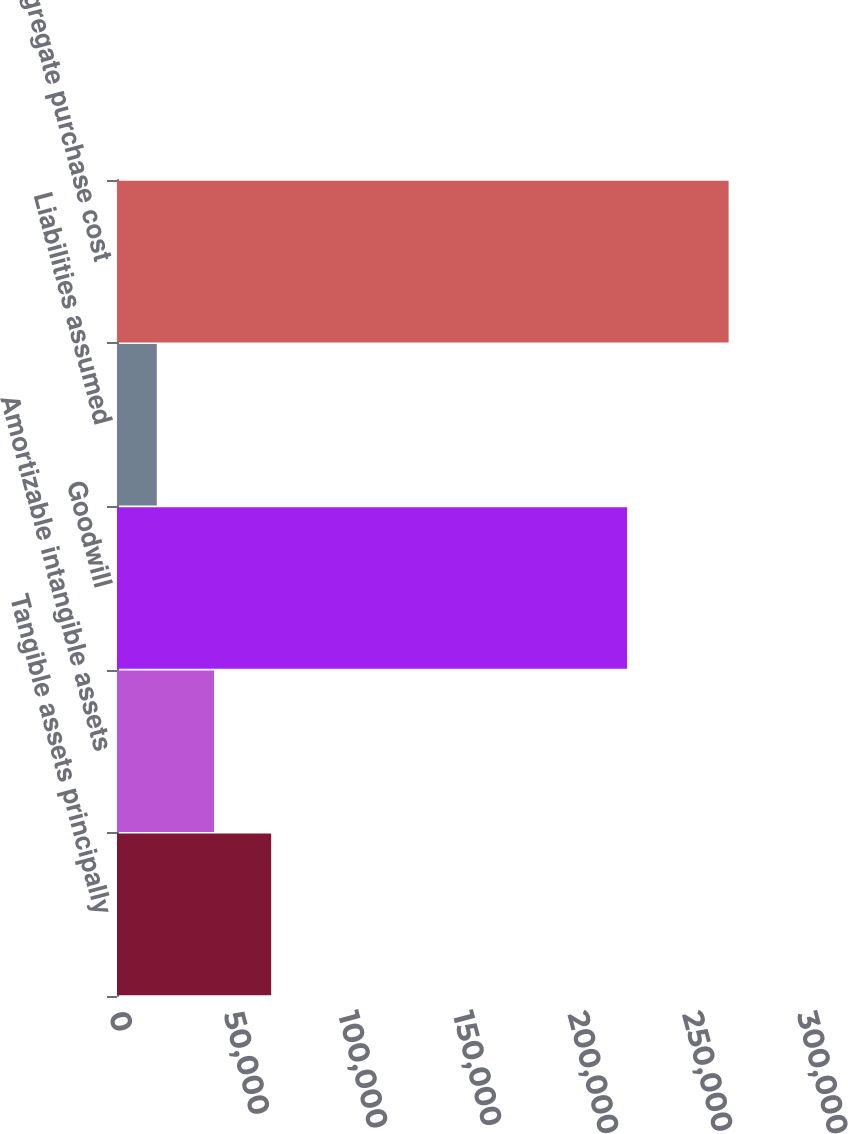Convert chart to OTSL. <chart><loc_0><loc_0><loc_500><loc_500><bar_chart><fcel>Tangible assets principally<fcel>Amortizable intangible assets<fcel>Goodwill<fcel>Liabilities assumed<fcel>Aggregate purchase cost<nl><fcel>67223.6<fcel>42289.8<fcel>222424<fcel>17356<fcel>266694<nl></chart> 